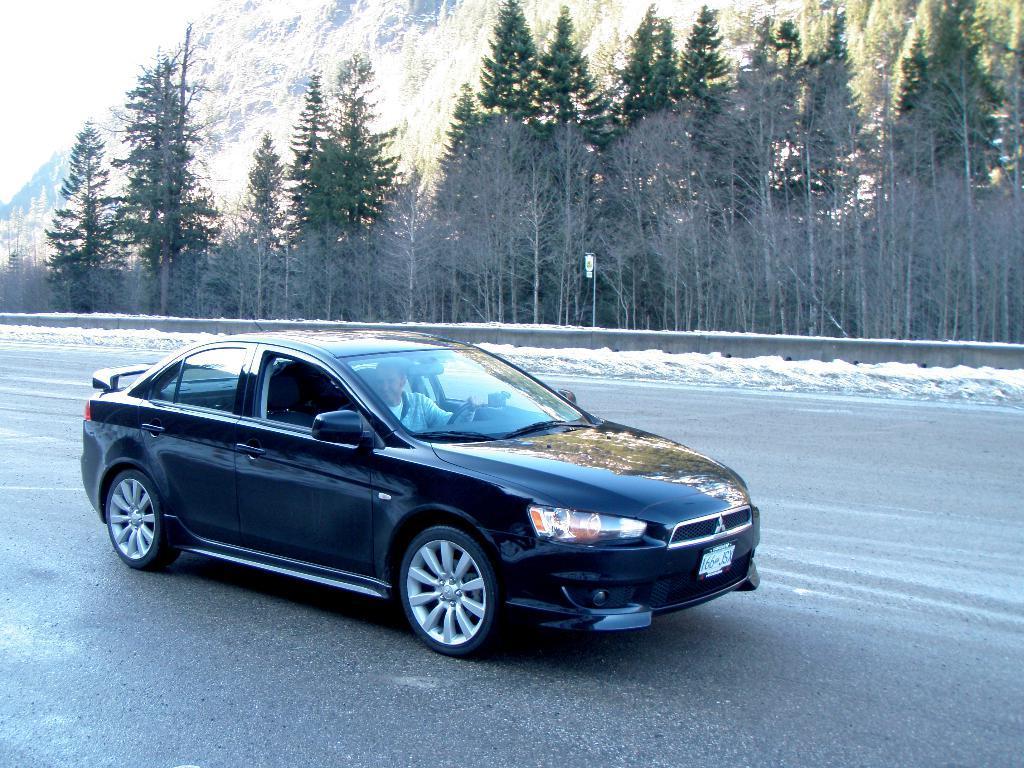Can you describe this image briefly? In the foreground of this picture, there is a black car moving on the road. In the background, there are trees, a pole and the sky. 